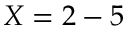Convert formula to latex. <formula><loc_0><loc_0><loc_500><loc_500>X = 2 - 5</formula> 